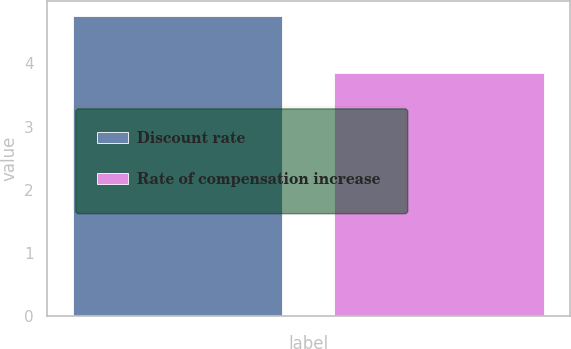Convert chart to OTSL. <chart><loc_0><loc_0><loc_500><loc_500><bar_chart><fcel>Discount rate<fcel>Rate of compensation increase<nl><fcel>4.75<fcel>3.85<nl></chart> 